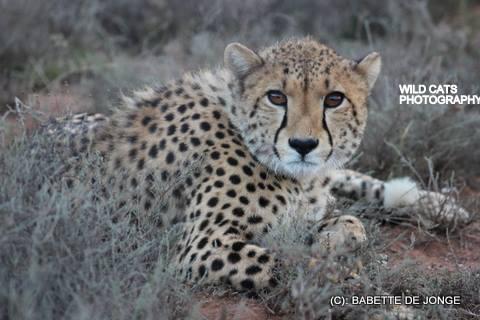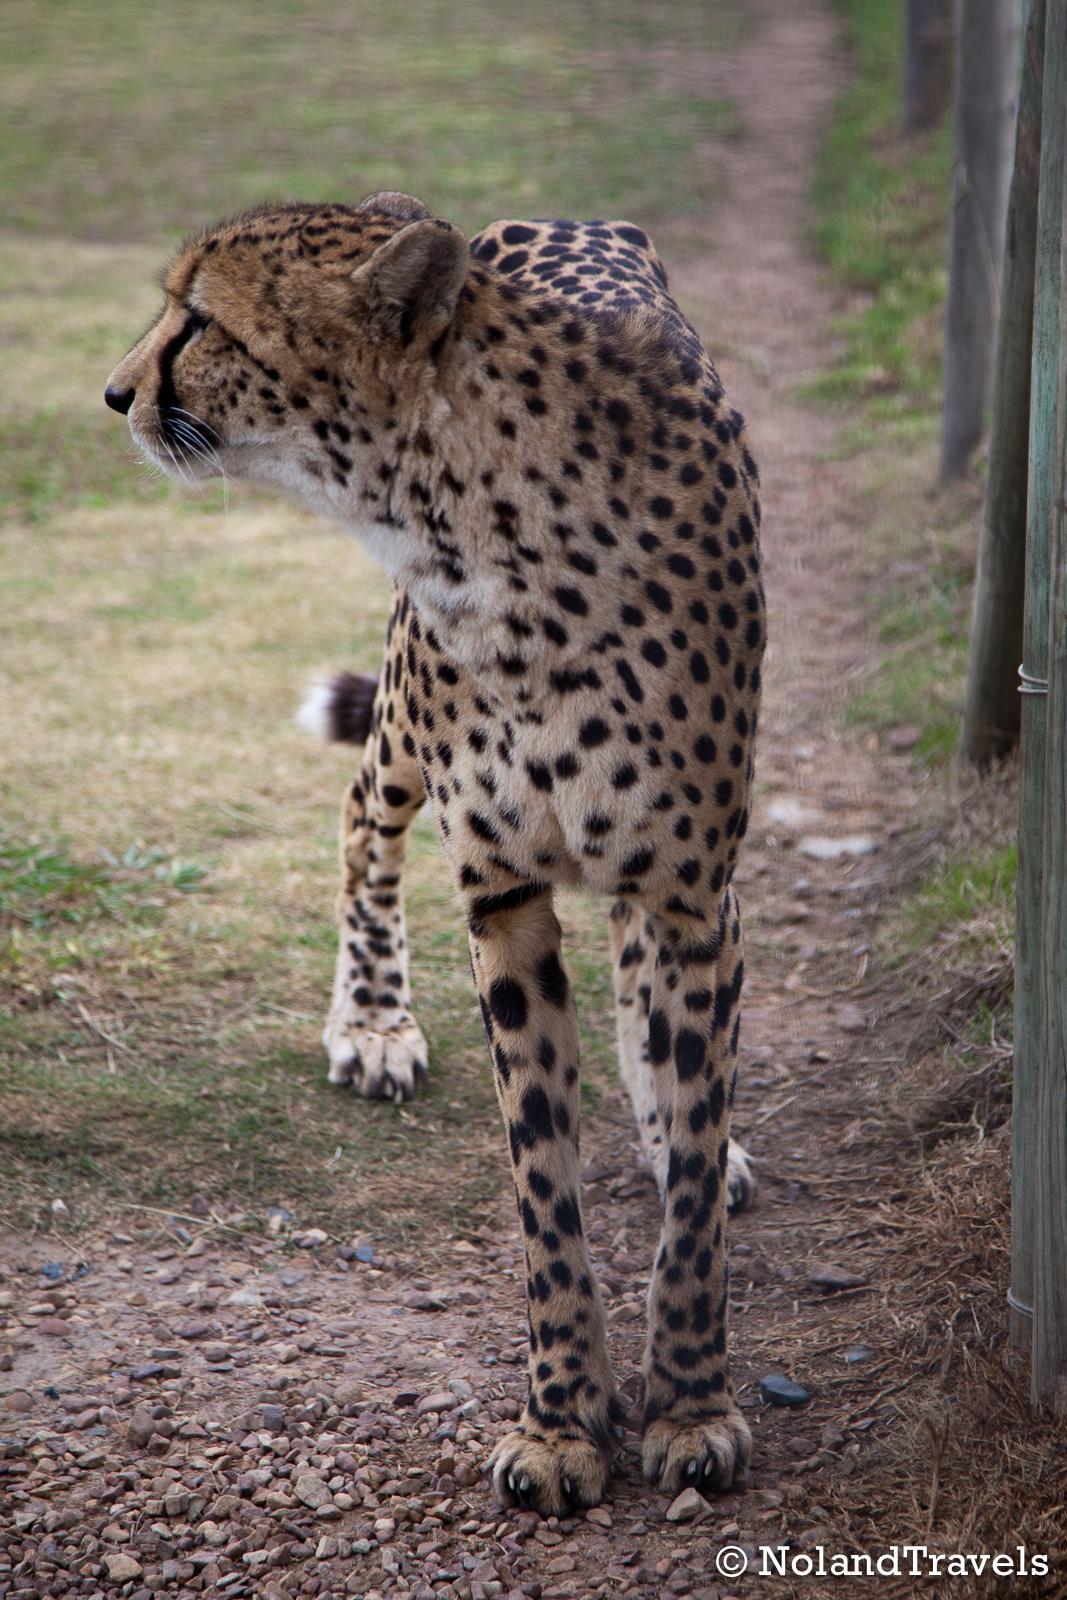The first image is the image on the left, the second image is the image on the right. Considering the images on both sides, is "At least one image shows an animal that is not a cheetah." valid? Answer yes or no. No. The first image is the image on the left, the second image is the image on the right. For the images displayed, is the sentence "A cheetah's front paws are off the ground." factually correct? Answer yes or no. No. 